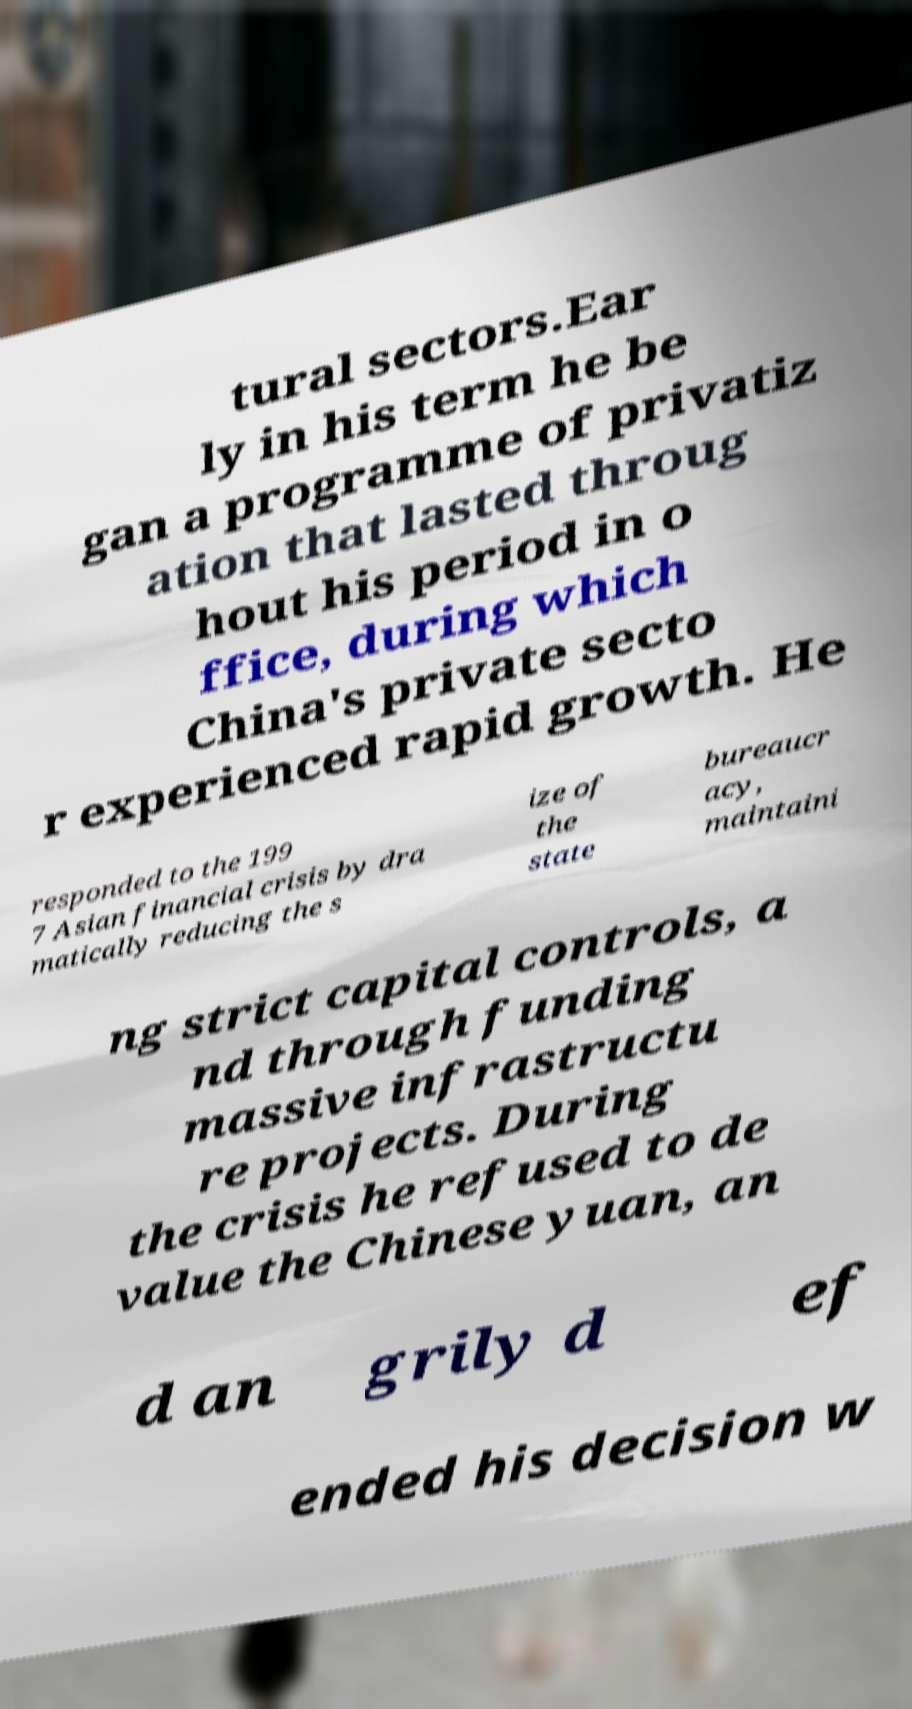Can you read and provide the text displayed in the image?This photo seems to have some interesting text. Can you extract and type it out for me? tural sectors.Ear ly in his term he be gan a programme of privatiz ation that lasted throug hout his period in o ffice, during which China's private secto r experienced rapid growth. He responded to the 199 7 Asian financial crisis by dra matically reducing the s ize of the state bureaucr acy, maintaini ng strict capital controls, a nd through funding massive infrastructu re projects. During the crisis he refused to de value the Chinese yuan, an d an grily d ef ended his decision w 